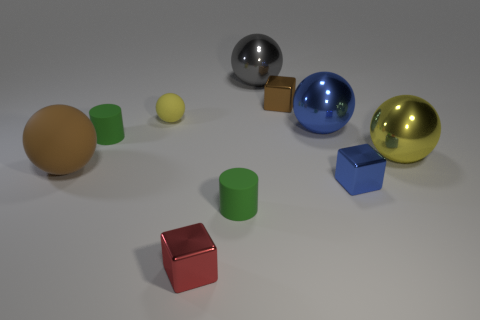There is a gray ball that is the same size as the brown matte ball; what is it made of?
Ensure brevity in your answer.  Metal. Is the size of the brown cube the same as the yellow ball that is on the left side of the gray sphere?
Ensure brevity in your answer.  Yes. There is a small green thing that is in front of the brown sphere; what is its material?
Your answer should be compact. Rubber. Is the number of blue metal objects behind the small blue thing the same as the number of gray objects?
Give a very brief answer. Yes. Do the blue sphere and the blue block have the same size?
Make the answer very short. No. There is a cube in front of the tiny green matte object right of the yellow matte ball; are there any green rubber things left of it?
Your answer should be compact. Yes. What is the material of the red thing that is the same shape as the tiny brown metal thing?
Your answer should be compact. Metal. There is a sphere that is left of the tiny yellow rubber ball; what number of rubber things are in front of it?
Make the answer very short. 1. What size is the yellow metal ball on the right side of the green cylinder that is right of the tiny green cylinder that is on the left side of the yellow matte sphere?
Make the answer very short. Large. There is a cube to the left of the ball that is behind the small brown object; what is its color?
Offer a terse response. Red. 